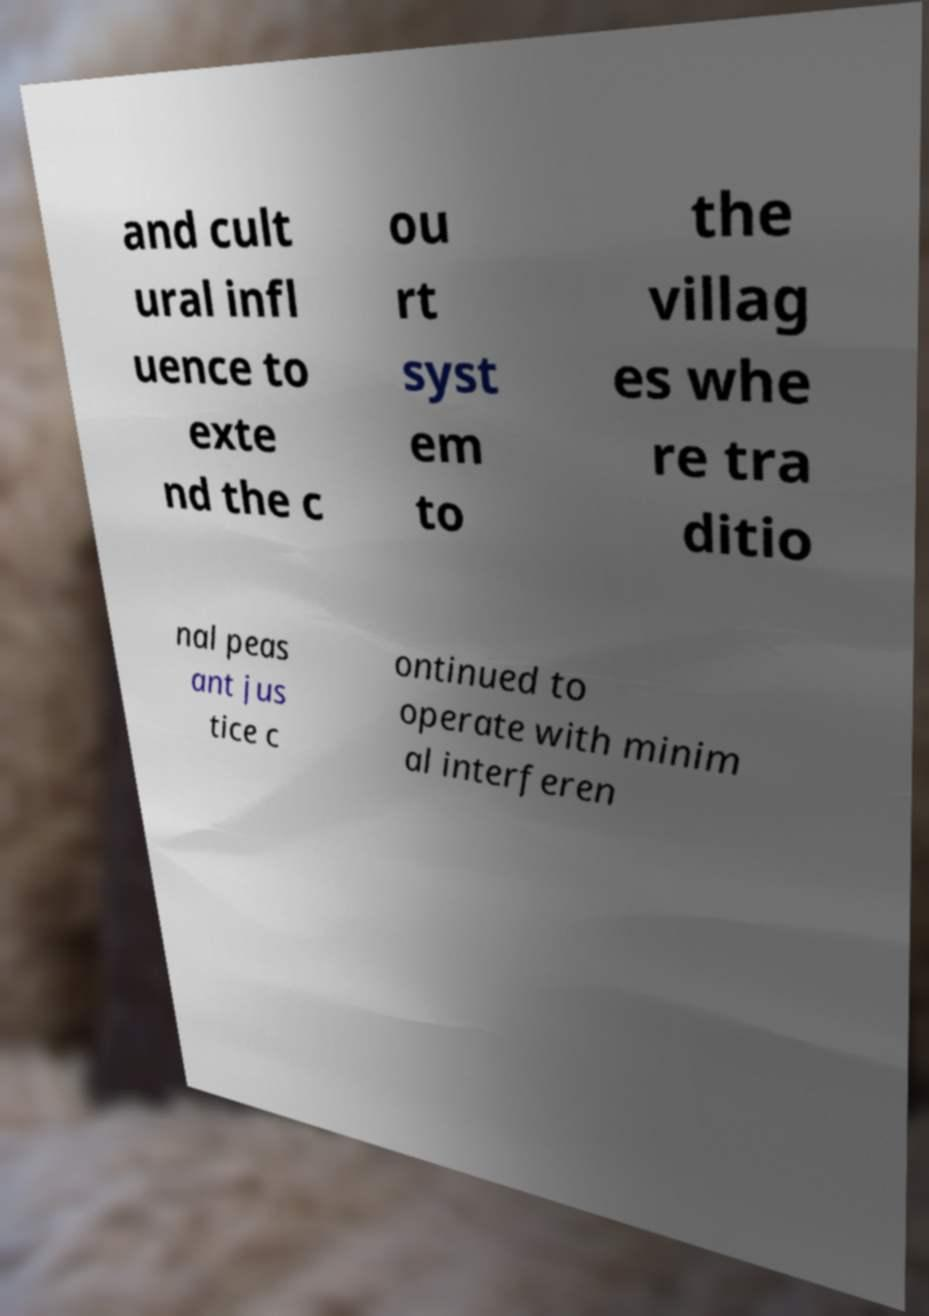Can you accurately transcribe the text from the provided image for me? and cult ural infl uence to exte nd the c ou rt syst em to the villag es whe re tra ditio nal peas ant jus tice c ontinued to operate with minim al interferen 